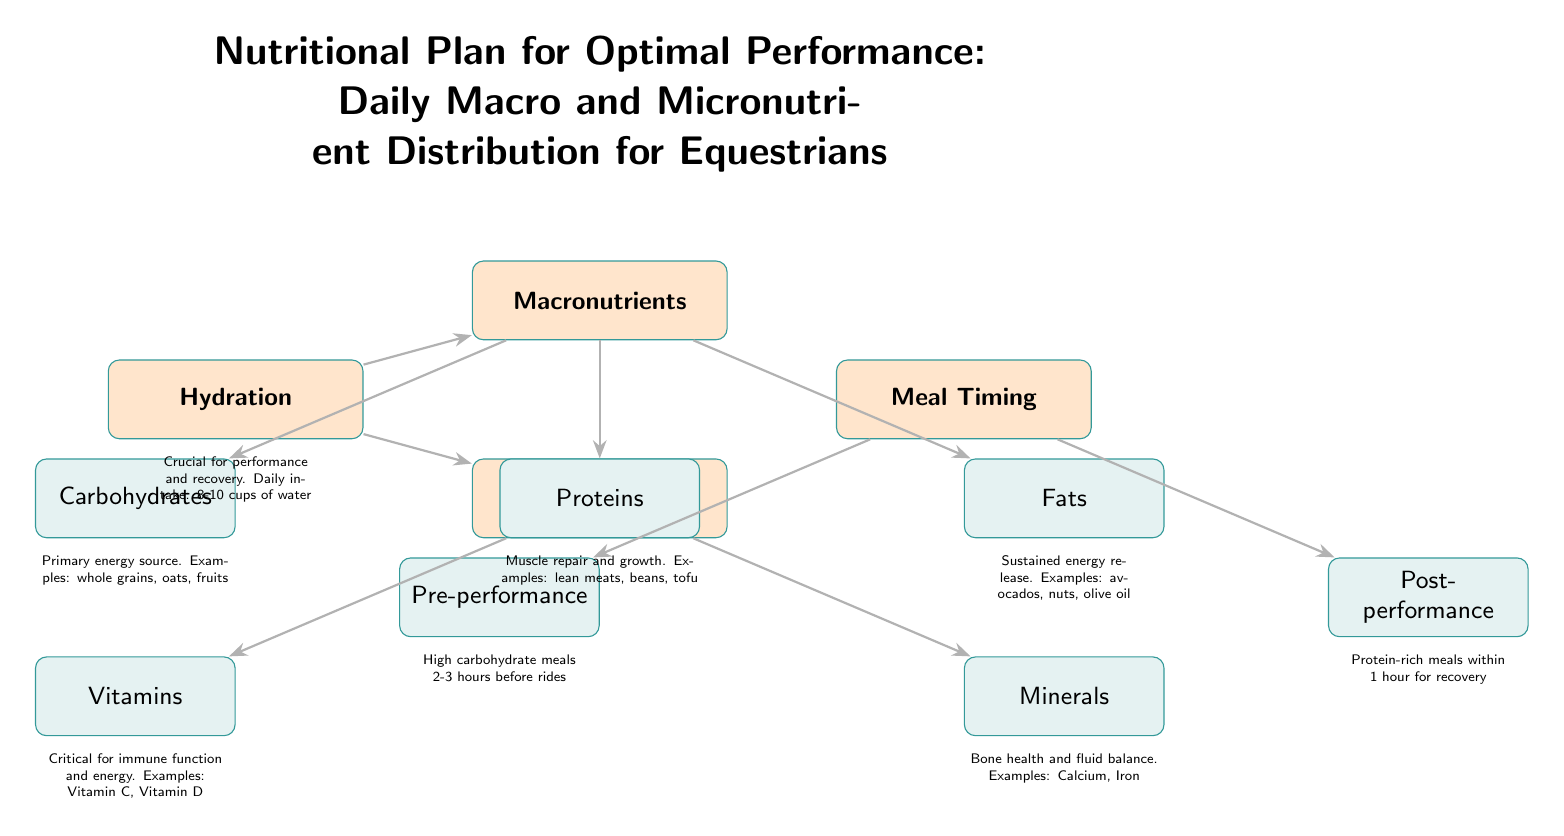What is the primary energy source for equestrians? The diagram indicates that carbohydrates are the primary energy source and lists them under macronutrients with an example of whole grains, oats, and fruits.
Answer: Carbohydrates How many types of macronutrients are listed in the diagram? The diagram includes three types of macronutrients: carbohydrates, proteins, and fats. Therefore, by counting these components, we find there are three types.
Answer: Three Which micronutrient category is essential for immune function? The diagram explicitly states that vitamins are critical for immune function and it is categorized under micronutrients with an example of Vitamin C and Vitamin D.
Answer: Vitamins What is the suggested daily water intake for optimal performance? The diagram notes that hydration is crucial for performance and recovery, stating a recommended daily intake of 8-10 cups of water. This numeric range provides the answer to the question.
Answer: 8-10 cups What type of meal should be consumed 2-3 hours before rides? According to the diagram, high carbohydrate meals are recommended to be consumed 2-3 hours before rides, as listed under meal timing. This indicates the type of meal necessary for optimal performance at that time.
Answer: High carbohydrate meals Which micronutrient is associated with bone health? The diagram indicates that minerals are important for bone health, highlighted in the context of micronutrients, along with examples like Calcium and Iron.
Answer: Minerals How does meal timing affect performance after riding? The diagram explains that protein-rich meals should be consumed within 1 hour of performance for recovery, connecting the meal timing node to the post-performance node for understanding its impact on recovery.
Answer: Protein-rich meals What does the arrow from hydration indicate in relation to macronutrients? The arrow shows a relationship, suggesting that hydration is a crucial factor impacting both macronutrients and micronutrients, indicating that hydration should not be overlooked in the overall nutrition plan.
Answer: Hydration impact How many nodes are there in the micronutrient section? There are two nodes identified in the micronutrient section: vitamins and minerals, thus resulting in a total of two nodes.
Answer: Two 